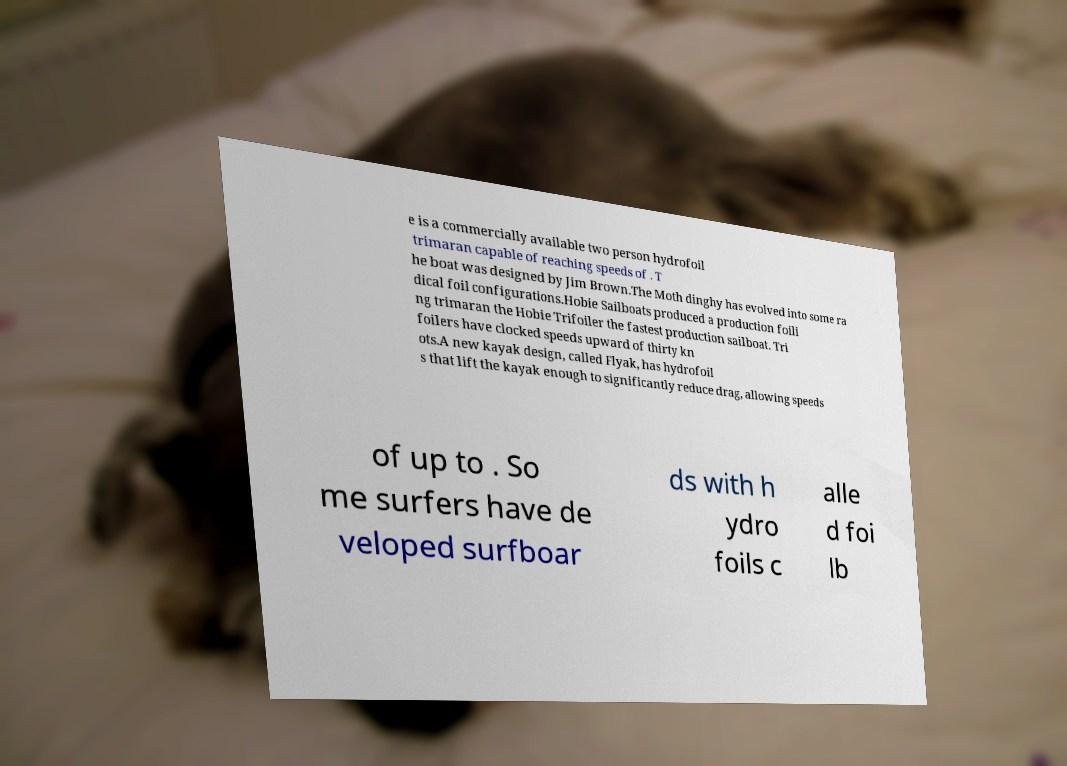Can you read and provide the text displayed in the image?This photo seems to have some interesting text. Can you extract and type it out for me? e is a commercially available two person hydrofoil trimaran capable of reaching speeds of . T he boat was designed by Jim Brown.The Moth dinghy has evolved into some ra dical foil configurations.Hobie Sailboats produced a production foili ng trimaran the Hobie Trifoiler the fastest production sailboat. Tri foilers have clocked speeds upward of thirty kn ots.A new kayak design, called Flyak, has hydrofoil s that lift the kayak enough to significantly reduce drag, allowing speeds of up to . So me surfers have de veloped surfboar ds with h ydro foils c alle d foi lb 